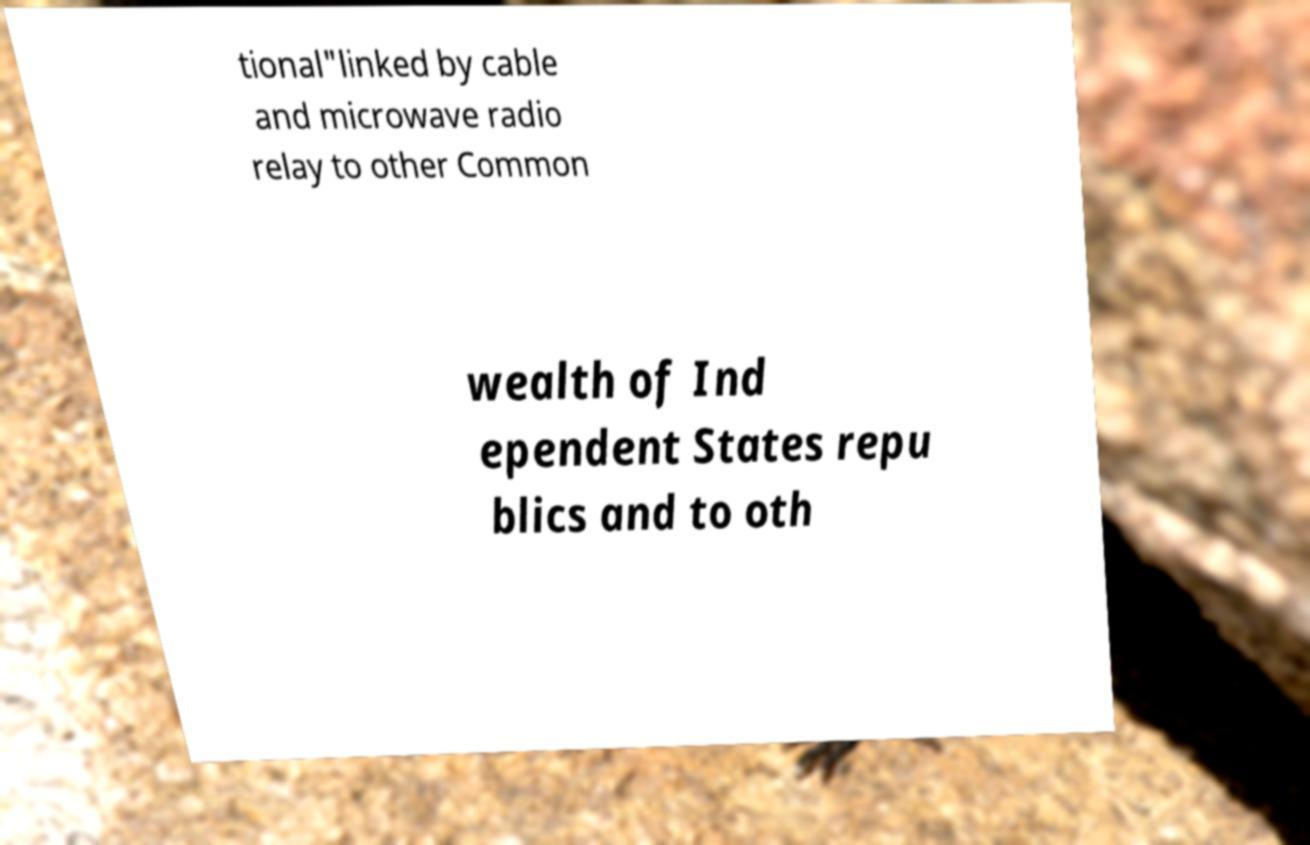There's text embedded in this image that I need extracted. Can you transcribe it verbatim? tional"linked by cable and microwave radio relay to other Common wealth of Ind ependent States repu blics and to oth 